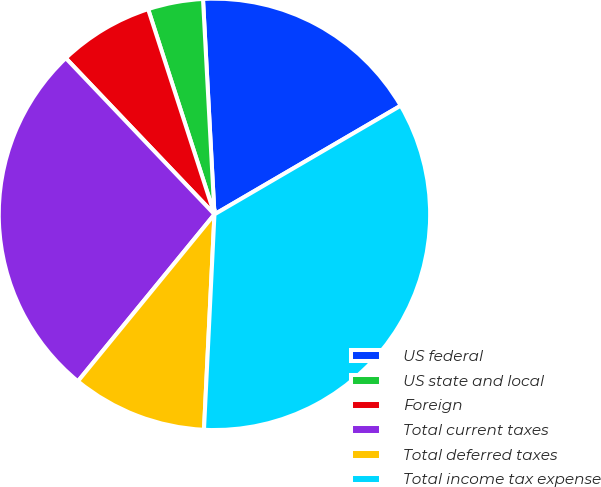<chart> <loc_0><loc_0><loc_500><loc_500><pie_chart><fcel>US federal<fcel>US state and local<fcel>Foreign<fcel>Total current taxes<fcel>Total deferred taxes<fcel>Total income tax expense<nl><fcel>17.44%<fcel>4.13%<fcel>7.13%<fcel>26.98%<fcel>10.14%<fcel>34.18%<nl></chart> 